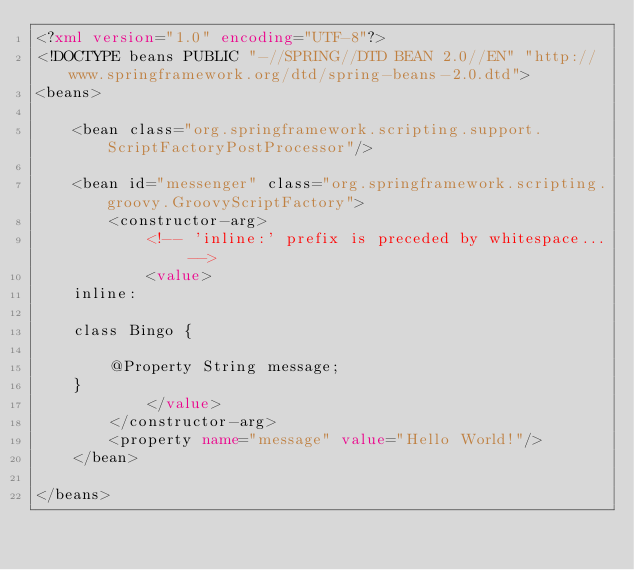Convert code to text. <code><loc_0><loc_0><loc_500><loc_500><_XML_><?xml version="1.0" encoding="UTF-8"?>
<!DOCTYPE beans PUBLIC "-//SPRING//DTD BEAN 2.0//EN" "http://www.springframework.org/dtd/spring-beans-2.0.dtd">
<beans>

	<bean class="org.springframework.scripting.support.ScriptFactoryPostProcessor"/>

	<bean id="messenger" class="org.springframework.scripting.groovy.GroovyScriptFactory">
		<constructor-arg>
			<!-- 'inline:' prefix is preceded by whitespace... -->
			<value>
    inline:
			
	class Bingo {

		@Property String message;
	}
			</value>
		</constructor-arg>
		<property name="message" value="Hello World!"/>
	</bean>

</beans>
</code> 